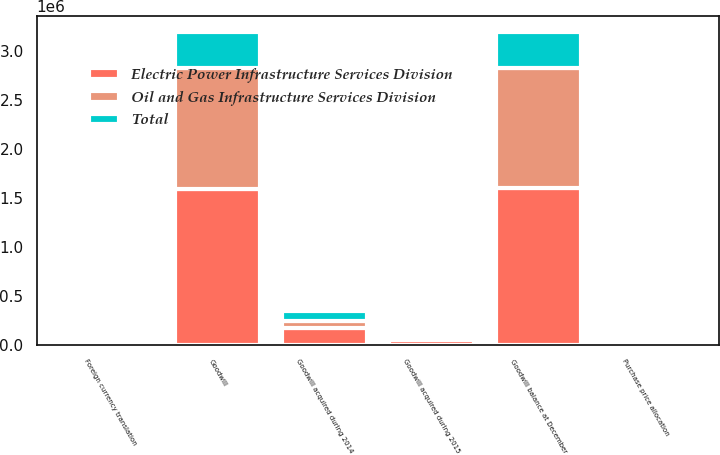<chart> <loc_0><loc_0><loc_500><loc_500><stacked_bar_chart><ecel><fcel>Goodwill balance at December<fcel>Goodwill acquired during 2014<fcel>Foreign currency translation<fcel>Goodwill acquired during 2015<fcel>Purchase price allocation<fcel>Goodwill<nl><fcel>Oil and Gas Infrastructure Services Division<fcel>1.22322e+06<fcel>71517<fcel>16377<fcel>31224<fcel>750<fcel>1.22624e+06<nl><fcel>Total<fcel>373471<fcel>102968<fcel>7340<fcel>20636<fcel>8867<fcel>366306<nl><fcel>Electric Power Infrastructure Services Division<fcel>1.5967e+06<fcel>174485<fcel>23717<fcel>51860<fcel>8117<fcel>1.59255e+06<nl></chart> 